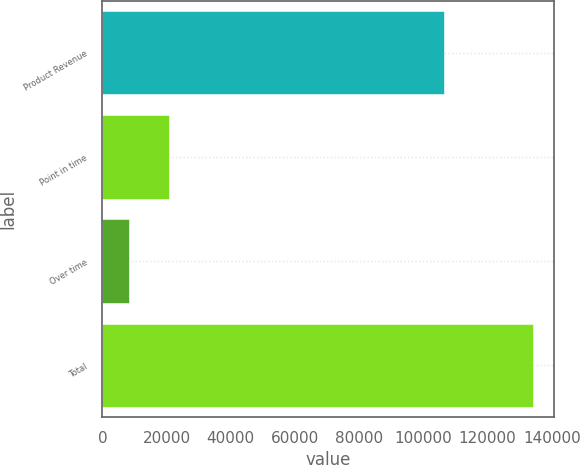Convert chart. <chart><loc_0><loc_0><loc_500><loc_500><bar_chart><fcel>Product Revenue<fcel>Point in time<fcel>Over time<fcel>Total<nl><fcel>106400<fcel>20817<fcel>8234<fcel>134064<nl></chart> 